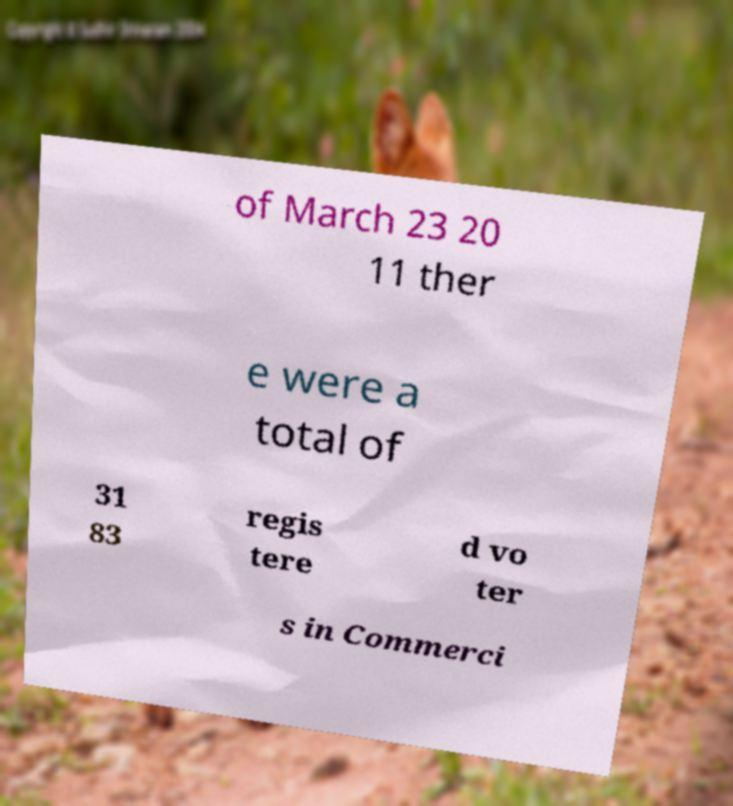What messages or text are displayed in this image? I need them in a readable, typed format. of March 23 20 11 ther e were a total of 31 83 regis tere d vo ter s in Commerci 